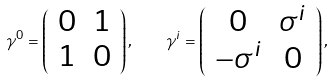Convert formula to latex. <formula><loc_0><loc_0><loc_500><loc_500>\gamma ^ { 0 } = \left ( \begin{array} { c c } 0 & 1 \\ 1 & 0 \end{array} \right ) , \quad \gamma ^ { i } = \left ( \begin{array} { c c } 0 & \sigma ^ { i } \\ - \sigma ^ { i } & 0 \end{array} \right ) ,</formula> 